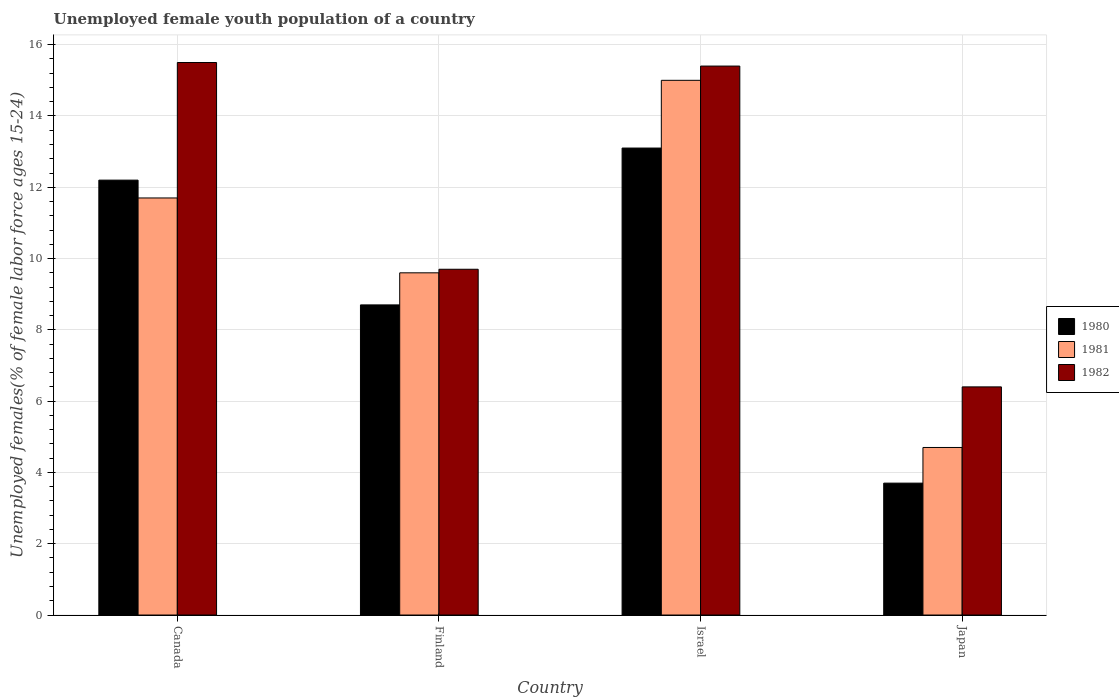Are the number of bars per tick equal to the number of legend labels?
Your answer should be very brief. Yes. Are the number of bars on each tick of the X-axis equal?
Offer a terse response. Yes. How many bars are there on the 3rd tick from the right?
Ensure brevity in your answer.  3. What is the label of the 1st group of bars from the left?
Offer a very short reply. Canada. In how many cases, is the number of bars for a given country not equal to the number of legend labels?
Your answer should be compact. 0. What is the percentage of unemployed female youth population in 1981 in Finland?
Ensure brevity in your answer.  9.6. Across all countries, what is the minimum percentage of unemployed female youth population in 1980?
Ensure brevity in your answer.  3.7. In which country was the percentage of unemployed female youth population in 1981 maximum?
Make the answer very short. Israel. In which country was the percentage of unemployed female youth population in 1982 minimum?
Provide a short and direct response. Japan. What is the total percentage of unemployed female youth population in 1982 in the graph?
Provide a short and direct response. 47. What is the difference between the percentage of unemployed female youth population in 1980 in Canada and that in Finland?
Your answer should be very brief. 3.5. What is the difference between the percentage of unemployed female youth population in 1980 in Canada and the percentage of unemployed female youth population in 1981 in Finland?
Provide a succinct answer. 2.6. What is the average percentage of unemployed female youth population in 1982 per country?
Make the answer very short. 11.75. What is the difference between the percentage of unemployed female youth population of/in 1982 and percentage of unemployed female youth population of/in 1981 in Israel?
Provide a succinct answer. 0.4. In how many countries, is the percentage of unemployed female youth population in 1982 greater than 8.8 %?
Ensure brevity in your answer.  3. What is the ratio of the percentage of unemployed female youth population in 1980 in Canada to that in Israel?
Provide a short and direct response. 0.93. Is the percentage of unemployed female youth population in 1980 in Israel less than that in Japan?
Ensure brevity in your answer.  No. Is the difference between the percentage of unemployed female youth population in 1982 in Canada and Israel greater than the difference between the percentage of unemployed female youth population in 1981 in Canada and Israel?
Give a very brief answer. Yes. What is the difference between the highest and the second highest percentage of unemployed female youth population in 1982?
Your answer should be compact. -5.7. What is the difference between the highest and the lowest percentage of unemployed female youth population in 1982?
Offer a very short reply. 9.1. In how many countries, is the percentage of unemployed female youth population in 1982 greater than the average percentage of unemployed female youth population in 1982 taken over all countries?
Keep it short and to the point. 2. Is the sum of the percentage of unemployed female youth population in 1980 in Canada and Israel greater than the maximum percentage of unemployed female youth population in 1982 across all countries?
Offer a terse response. Yes. What does the 1st bar from the left in Japan represents?
Offer a very short reply. 1980. How many legend labels are there?
Offer a terse response. 3. What is the title of the graph?
Give a very brief answer. Unemployed female youth population of a country. Does "1966" appear as one of the legend labels in the graph?
Give a very brief answer. No. What is the label or title of the X-axis?
Make the answer very short. Country. What is the label or title of the Y-axis?
Offer a terse response. Unemployed females(% of female labor force ages 15-24). What is the Unemployed females(% of female labor force ages 15-24) of 1980 in Canada?
Provide a short and direct response. 12.2. What is the Unemployed females(% of female labor force ages 15-24) in 1981 in Canada?
Provide a succinct answer. 11.7. What is the Unemployed females(% of female labor force ages 15-24) of 1980 in Finland?
Provide a succinct answer. 8.7. What is the Unemployed females(% of female labor force ages 15-24) in 1981 in Finland?
Your response must be concise. 9.6. What is the Unemployed females(% of female labor force ages 15-24) of 1982 in Finland?
Your answer should be compact. 9.7. What is the Unemployed females(% of female labor force ages 15-24) of 1980 in Israel?
Give a very brief answer. 13.1. What is the Unemployed females(% of female labor force ages 15-24) in 1981 in Israel?
Ensure brevity in your answer.  15. What is the Unemployed females(% of female labor force ages 15-24) in 1982 in Israel?
Offer a terse response. 15.4. What is the Unemployed females(% of female labor force ages 15-24) in 1980 in Japan?
Offer a very short reply. 3.7. What is the Unemployed females(% of female labor force ages 15-24) in 1981 in Japan?
Offer a terse response. 4.7. What is the Unemployed females(% of female labor force ages 15-24) of 1982 in Japan?
Keep it short and to the point. 6.4. Across all countries, what is the maximum Unemployed females(% of female labor force ages 15-24) in 1980?
Provide a succinct answer. 13.1. Across all countries, what is the minimum Unemployed females(% of female labor force ages 15-24) of 1980?
Provide a succinct answer. 3.7. Across all countries, what is the minimum Unemployed females(% of female labor force ages 15-24) in 1981?
Provide a short and direct response. 4.7. Across all countries, what is the minimum Unemployed females(% of female labor force ages 15-24) in 1982?
Offer a terse response. 6.4. What is the total Unemployed females(% of female labor force ages 15-24) in 1980 in the graph?
Give a very brief answer. 37.7. What is the total Unemployed females(% of female labor force ages 15-24) in 1981 in the graph?
Offer a terse response. 41. What is the total Unemployed females(% of female labor force ages 15-24) of 1982 in the graph?
Your answer should be compact. 47. What is the difference between the Unemployed females(% of female labor force ages 15-24) of 1981 in Canada and that in Finland?
Give a very brief answer. 2.1. What is the difference between the Unemployed females(% of female labor force ages 15-24) of 1980 in Canada and that in Israel?
Offer a terse response. -0.9. What is the difference between the Unemployed females(% of female labor force ages 15-24) of 1982 in Canada and that in Israel?
Your answer should be very brief. 0.1. What is the difference between the Unemployed females(% of female labor force ages 15-24) of 1981 in Finland and that in Israel?
Your answer should be very brief. -5.4. What is the difference between the Unemployed females(% of female labor force ages 15-24) of 1981 in Finland and that in Japan?
Your answer should be very brief. 4.9. What is the difference between the Unemployed females(% of female labor force ages 15-24) of 1982 in Finland and that in Japan?
Provide a succinct answer. 3.3. What is the difference between the Unemployed females(% of female labor force ages 15-24) of 1980 in Israel and that in Japan?
Your answer should be compact. 9.4. What is the difference between the Unemployed females(% of female labor force ages 15-24) in 1980 in Canada and the Unemployed females(% of female labor force ages 15-24) in 1982 in Finland?
Your answer should be very brief. 2.5. What is the difference between the Unemployed females(% of female labor force ages 15-24) of 1981 in Canada and the Unemployed females(% of female labor force ages 15-24) of 1982 in Finland?
Offer a very short reply. 2. What is the difference between the Unemployed females(% of female labor force ages 15-24) in 1980 in Canada and the Unemployed females(% of female labor force ages 15-24) in 1982 in Israel?
Offer a very short reply. -3.2. What is the difference between the Unemployed females(% of female labor force ages 15-24) of 1981 in Canada and the Unemployed females(% of female labor force ages 15-24) of 1982 in Israel?
Your response must be concise. -3.7. What is the difference between the Unemployed females(% of female labor force ages 15-24) of 1980 in Canada and the Unemployed females(% of female labor force ages 15-24) of 1981 in Japan?
Give a very brief answer. 7.5. What is the difference between the Unemployed females(% of female labor force ages 15-24) of 1980 in Finland and the Unemployed females(% of female labor force ages 15-24) of 1982 in Israel?
Provide a succinct answer. -6.7. What is the difference between the Unemployed females(% of female labor force ages 15-24) in 1981 in Finland and the Unemployed females(% of female labor force ages 15-24) in 1982 in Israel?
Give a very brief answer. -5.8. What is the difference between the Unemployed females(% of female labor force ages 15-24) of 1980 in Israel and the Unemployed females(% of female labor force ages 15-24) of 1981 in Japan?
Your answer should be very brief. 8.4. What is the difference between the Unemployed females(% of female labor force ages 15-24) of 1980 in Israel and the Unemployed females(% of female labor force ages 15-24) of 1982 in Japan?
Your answer should be compact. 6.7. What is the difference between the Unemployed females(% of female labor force ages 15-24) of 1981 in Israel and the Unemployed females(% of female labor force ages 15-24) of 1982 in Japan?
Make the answer very short. 8.6. What is the average Unemployed females(% of female labor force ages 15-24) in 1980 per country?
Make the answer very short. 9.43. What is the average Unemployed females(% of female labor force ages 15-24) in 1981 per country?
Your answer should be very brief. 10.25. What is the average Unemployed females(% of female labor force ages 15-24) in 1982 per country?
Keep it short and to the point. 11.75. What is the difference between the Unemployed females(% of female labor force ages 15-24) of 1980 and Unemployed females(% of female labor force ages 15-24) of 1982 in Canada?
Ensure brevity in your answer.  -3.3. What is the difference between the Unemployed females(% of female labor force ages 15-24) in 1981 and Unemployed females(% of female labor force ages 15-24) in 1982 in Canada?
Offer a terse response. -3.8. What is the difference between the Unemployed females(% of female labor force ages 15-24) of 1980 and Unemployed females(% of female labor force ages 15-24) of 1981 in Finland?
Your response must be concise. -0.9. What is the difference between the Unemployed females(% of female labor force ages 15-24) in 1981 and Unemployed females(% of female labor force ages 15-24) in 1982 in Finland?
Ensure brevity in your answer.  -0.1. What is the difference between the Unemployed females(% of female labor force ages 15-24) in 1981 and Unemployed females(% of female labor force ages 15-24) in 1982 in Israel?
Your answer should be very brief. -0.4. What is the difference between the Unemployed females(% of female labor force ages 15-24) of 1980 and Unemployed females(% of female labor force ages 15-24) of 1981 in Japan?
Keep it short and to the point. -1. What is the difference between the Unemployed females(% of female labor force ages 15-24) in 1980 and Unemployed females(% of female labor force ages 15-24) in 1982 in Japan?
Offer a terse response. -2.7. What is the difference between the Unemployed females(% of female labor force ages 15-24) in 1981 and Unemployed females(% of female labor force ages 15-24) in 1982 in Japan?
Make the answer very short. -1.7. What is the ratio of the Unemployed females(% of female labor force ages 15-24) in 1980 in Canada to that in Finland?
Make the answer very short. 1.4. What is the ratio of the Unemployed females(% of female labor force ages 15-24) of 1981 in Canada to that in Finland?
Make the answer very short. 1.22. What is the ratio of the Unemployed females(% of female labor force ages 15-24) of 1982 in Canada to that in Finland?
Your answer should be compact. 1.6. What is the ratio of the Unemployed females(% of female labor force ages 15-24) in 1980 in Canada to that in Israel?
Give a very brief answer. 0.93. What is the ratio of the Unemployed females(% of female labor force ages 15-24) in 1981 in Canada to that in Israel?
Keep it short and to the point. 0.78. What is the ratio of the Unemployed females(% of female labor force ages 15-24) in 1980 in Canada to that in Japan?
Offer a terse response. 3.3. What is the ratio of the Unemployed females(% of female labor force ages 15-24) in 1981 in Canada to that in Japan?
Your answer should be compact. 2.49. What is the ratio of the Unemployed females(% of female labor force ages 15-24) in 1982 in Canada to that in Japan?
Ensure brevity in your answer.  2.42. What is the ratio of the Unemployed females(% of female labor force ages 15-24) in 1980 in Finland to that in Israel?
Your answer should be compact. 0.66. What is the ratio of the Unemployed females(% of female labor force ages 15-24) in 1981 in Finland to that in Israel?
Provide a short and direct response. 0.64. What is the ratio of the Unemployed females(% of female labor force ages 15-24) of 1982 in Finland to that in Israel?
Ensure brevity in your answer.  0.63. What is the ratio of the Unemployed females(% of female labor force ages 15-24) in 1980 in Finland to that in Japan?
Your answer should be very brief. 2.35. What is the ratio of the Unemployed females(% of female labor force ages 15-24) in 1981 in Finland to that in Japan?
Offer a very short reply. 2.04. What is the ratio of the Unemployed females(% of female labor force ages 15-24) of 1982 in Finland to that in Japan?
Keep it short and to the point. 1.52. What is the ratio of the Unemployed females(% of female labor force ages 15-24) of 1980 in Israel to that in Japan?
Keep it short and to the point. 3.54. What is the ratio of the Unemployed females(% of female labor force ages 15-24) of 1981 in Israel to that in Japan?
Offer a terse response. 3.19. What is the ratio of the Unemployed females(% of female labor force ages 15-24) in 1982 in Israel to that in Japan?
Keep it short and to the point. 2.41. What is the difference between the highest and the second highest Unemployed females(% of female labor force ages 15-24) in 1980?
Ensure brevity in your answer.  0.9. What is the difference between the highest and the second highest Unemployed females(% of female labor force ages 15-24) of 1981?
Ensure brevity in your answer.  3.3. What is the difference between the highest and the lowest Unemployed females(% of female labor force ages 15-24) in 1980?
Your answer should be compact. 9.4. 